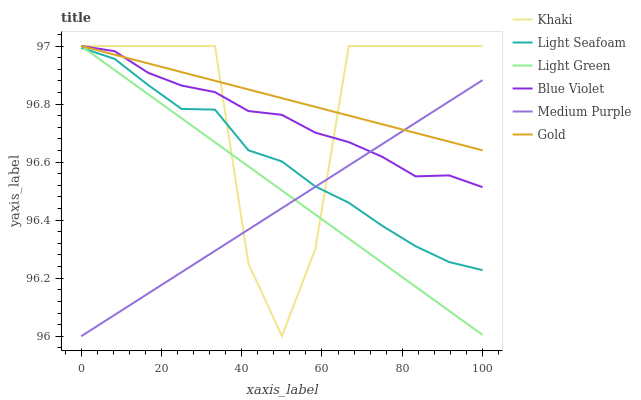Does Gold have the minimum area under the curve?
Answer yes or no. No. Does Medium Purple have the maximum area under the curve?
Answer yes or no. No. Is Gold the smoothest?
Answer yes or no. No. Is Gold the roughest?
Answer yes or no. No. Does Gold have the lowest value?
Answer yes or no. No. Does Medium Purple have the highest value?
Answer yes or no. No. Is Light Seafoam less than Gold?
Answer yes or no. Yes. Is Blue Violet greater than Light Seafoam?
Answer yes or no. Yes. Does Light Seafoam intersect Gold?
Answer yes or no. No. 